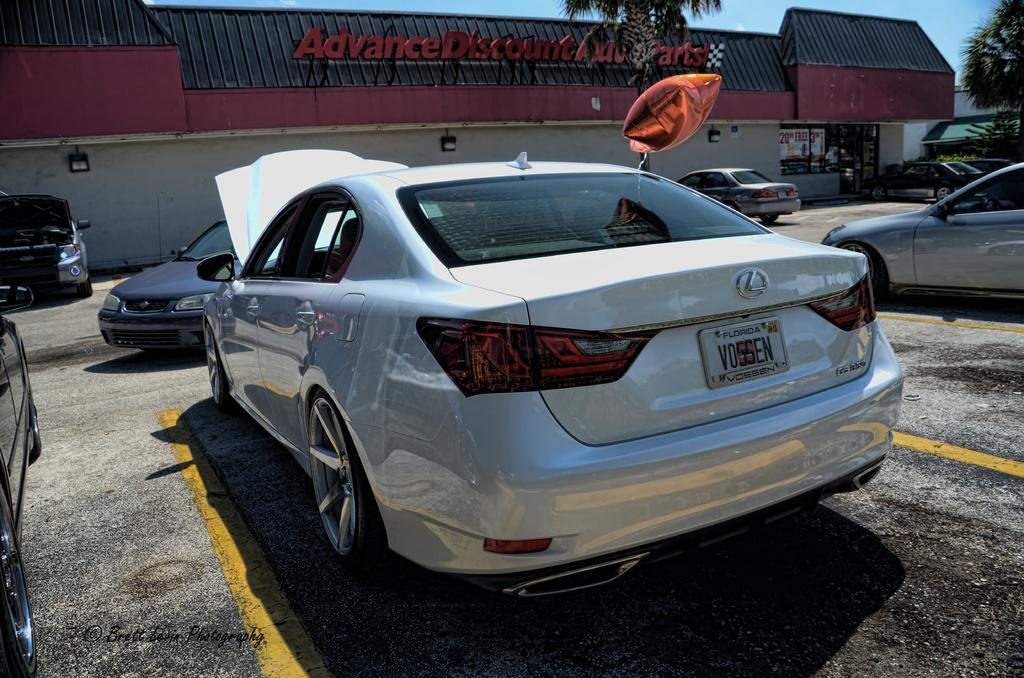What can be seen in the image related to vehicles? There are cars parked in the image. Where are the cars located? The cars are in a parking lot. What can be seen in the background of the image? There is a building, trees, and the sky visible in the background of the image. How far away is the hammer from the cars in the image? There is no hammer present in the image, so it cannot be determined how far away it is from the cars. 